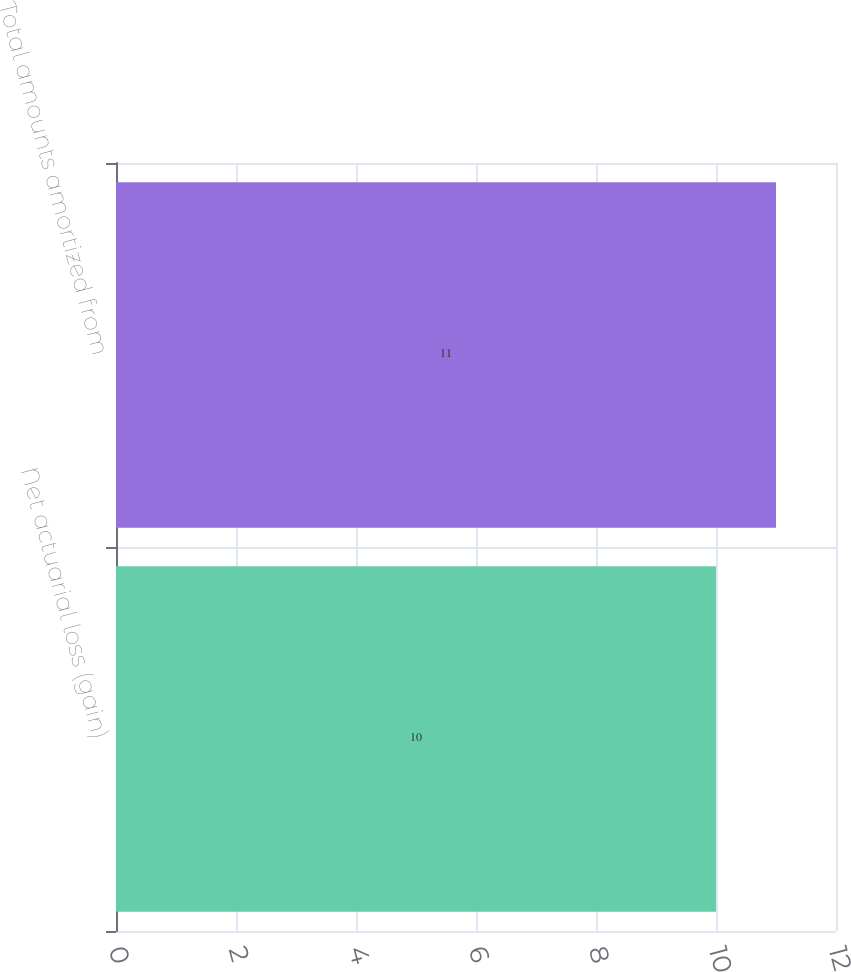Convert chart. <chart><loc_0><loc_0><loc_500><loc_500><bar_chart><fcel>Net actuarial loss (gain)<fcel>Total amounts amortized from<nl><fcel>10<fcel>11<nl></chart> 